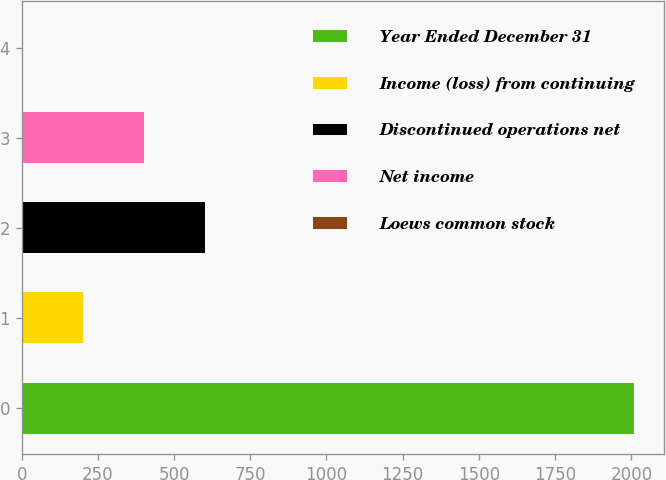<chart> <loc_0><loc_0><loc_500><loc_500><bar_chart><fcel>Year Ended December 31<fcel>Income (loss) from continuing<fcel>Discontinued operations net<fcel>Net income<fcel>Loews common stock<nl><fcel>2008<fcel>201.03<fcel>602.59<fcel>401.81<fcel>0.25<nl></chart> 